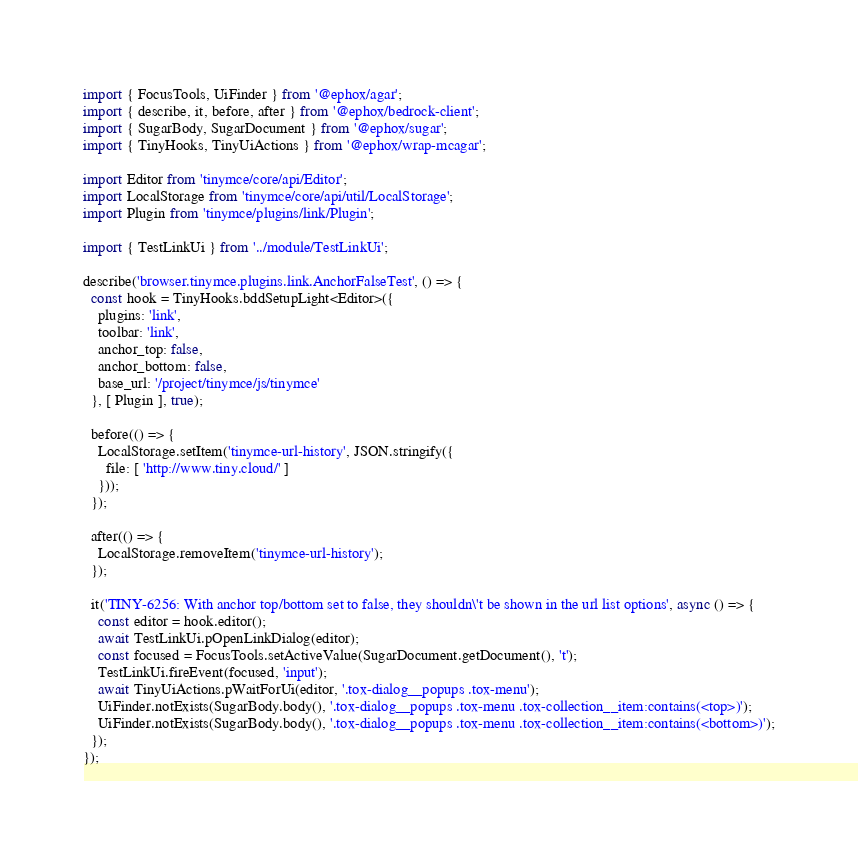Convert code to text. <code><loc_0><loc_0><loc_500><loc_500><_TypeScript_>import { FocusTools, UiFinder } from '@ephox/agar';
import { describe, it, before, after } from '@ephox/bedrock-client';
import { SugarBody, SugarDocument } from '@ephox/sugar';
import { TinyHooks, TinyUiActions } from '@ephox/wrap-mcagar';

import Editor from 'tinymce/core/api/Editor';
import LocalStorage from 'tinymce/core/api/util/LocalStorage';
import Plugin from 'tinymce/plugins/link/Plugin';

import { TestLinkUi } from '../module/TestLinkUi';

describe('browser.tinymce.plugins.link.AnchorFalseTest', () => {
  const hook = TinyHooks.bddSetupLight<Editor>({
    plugins: 'link',
    toolbar: 'link',
    anchor_top: false,
    anchor_bottom: false,
    base_url: '/project/tinymce/js/tinymce'
  }, [ Plugin ], true);

  before(() => {
    LocalStorage.setItem('tinymce-url-history', JSON.stringify({
      file: [ 'http://www.tiny.cloud/' ]
    }));
  });

  after(() => {
    LocalStorage.removeItem('tinymce-url-history');
  });

  it('TINY-6256: With anchor top/bottom set to false, they shouldn\'t be shown in the url list options', async () => {
    const editor = hook.editor();
    await TestLinkUi.pOpenLinkDialog(editor);
    const focused = FocusTools.setActiveValue(SugarDocument.getDocument(), 't');
    TestLinkUi.fireEvent(focused, 'input');
    await TinyUiActions.pWaitForUi(editor, '.tox-dialog__popups .tox-menu');
    UiFinder.notExists(SugarBody.body(), '.tox-dialog__popups .tox-menu .tox-collection__item:contains(<top>)');
    UiFinder.notExists(SugarBody.body(), '.tox-dialog__popups .tox-menu .tox-collection__item:contains(<bottom>)');
  });
});
</code> 